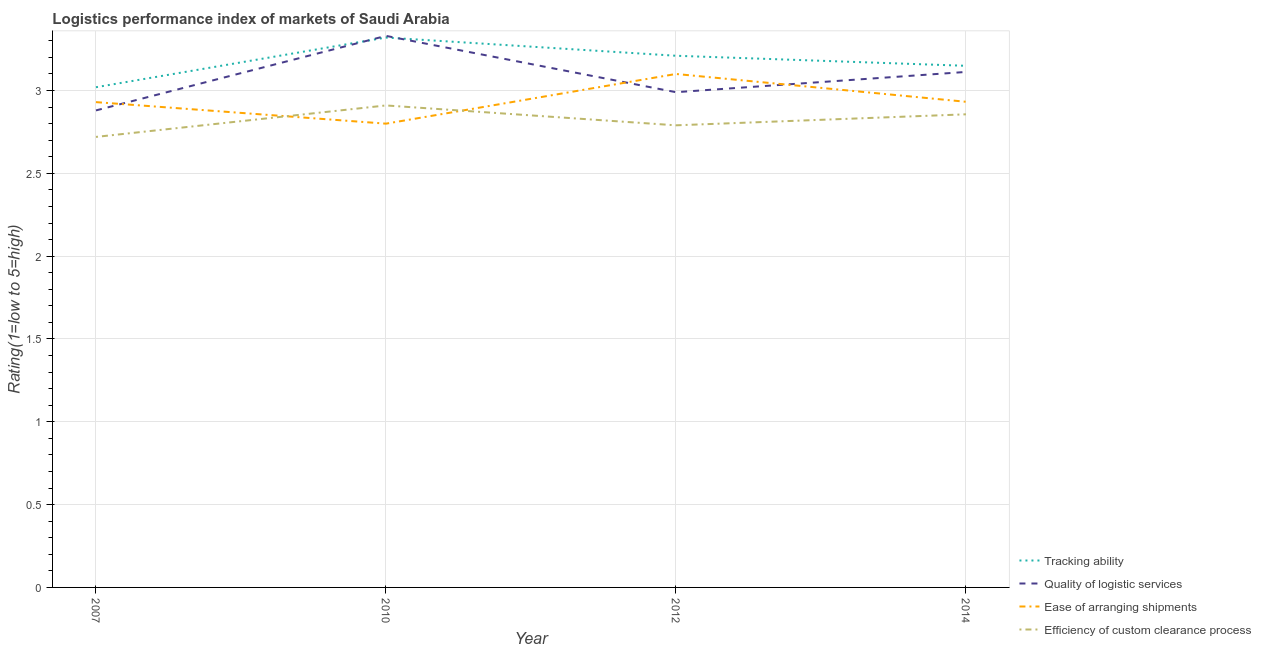How many different coloured lines are there?
Ensure brevity in your answer.  4. Does the line corresponding to lpi rating of efficiency of custom clearance process intersect with the line corresponding to lpi rating of quality of logistic services?
Your answer should be compact. No. Is the number of lines equal to the number of legend labels?
Your response must be concise. Yes. What is the lpi rating of efficiency of custom clearance process in 2014?
Your response must be concise. 2.86. Across all years, what is the maximum lpi rating of quality of logistic services?
Provide a short and direct response. 3.33. Across all years, what is the minimum lpi rating of tracking ability?
Ensure brevity in your answer.  3.02. In which year was the lpi rating of ease of arranging shipments maximum?
Keep it short and to the point. 2012. In which year was the lpi rating of efficiency of custom clearance process minimum?
Provide a succinct answer. 2007. What is the total lpi rating of ease of arranging shipments in the graph?
Offer a very short reply. 11.76. What is the difference between the lpi rating of ease of arranging shipments in 2010 and that in 2012?
Your answer should be compact. -0.3. What is the difference between the lpi rating of ease of arranging shipments in 2014 and the lpi rating of efficiency of custom clearance process in 2010?
Make the answer very short. 0.02. What is the average lpi rating of efficiency of custom clearance process per year?
Offer a terse response. 2.82. In the year 2012, what is the difference between the lpi rating of efficiency of custom clearance process and lpi rating of ease of arranging shipments?
Your answer should be compact. -0.31. In how many years, is the lpi rating of quality of logistic services greater than 2.1?
Keep it short and to the point. 4. What is the ratio of the lpi rating of quality of logistic services in 2007 to that in 2012?
Your response must be concise. 0.96. What is the difference between the highest and the second highest lpi rating of quality of logistic services?
Make the answer very short. 0.22. What is the difference between the highest and the lowest lpi rating of ease of arranging shipments?
Give a very brief answer. 0.3. In how many years, is the lpi rating of tracking ability greater than the average lpi rating of tracking ability taken over all years?
Your answer should be compact. 2. Is the sum of the lpi rating of efficiency of custom clearance process in 2010 and 2014 greater than the maximum lpi rating of quality of logistic services across all years?
Your answer should be compact. Yes. Is it the case that in every year, the sum of the lpi rating of tracking ability and lpi rating of ease of arranging shipments is greater than the sum of lpi rating of efficiency of custom clearance process and lpi rating of quality of logistic services?
Offer a terse response. Yes. Is the lpi rating of quality of logistic services strictly less than the lpi rating of efficiency of custom clearance process over the years?
Keep it short and to the point. No. How many years are there in the graph?
Your answer should be compact. 4. Are the values on the major ticks of Y-axis written in scientific E-notation?
Offer a terse response. No. Does the graph contain any zero values?
Offer a very short reply. No. Does the graph contain grids?
Give a very brief answer. Yes. Where does the legend appear in the graph?
Ensure brevity in your answer.  Bottom right. How many legend labels are there?
Make the answer very short. 4. How are the legend labels stacked?
Your answer should be compact. Vertical. What is the title of the graph?
Ensure brevity in your answer.  Logistics performance index of markets of Saudi Arabia. What is the label or title of the Y-axis?
Keep it short and to the point. Rating(1=low to 5=high). What is the Rating(1=low to 5=high) of Tracking ability in 2007?
Provide a succinct answer. 3.02. What is the Rating(1=low to 5=high) of Quality of logistic services in 2007?
Make the answer very short. 2.88. What is the Rating(1=low to 5=high) in Ease of arranging shipments in 2007?
Ensure brevity in your answer.  2.93. What is the Rating(1=low to 5=high) in Efficiency of custom clearance process in 2007?
Provide a short and direct response. 2.72. What is the Rating(1=low to 5=high) of Tracking ability in 2010?
Offer a terse response. 3.32. What is the Rating(1=low to 5=high) in Quality of logistic services in 2010?
Keep it short and to the point. 3.33. What is the Rating(1=low to 5=high) of Ease of arranging shipments in 2010?
Make the answer very short. 2.8. What is the Rating(1=low to 5=high) in Efficiency of custom clearance process in 2010?
Offer a very short reply. 2.91. What is the Rating(1=low to 5=high) of Tracking ability in 2012?
Your answer should be very brief. 3.21. What is the Rating(1=low to 5=high) in Quality of logistic services in 2012?
Offer a very short reply. 2.99. What is the Rating(1=low to 5=high) in Efficiency of custom clearance process in 2012?
Your answer should be very brief. 2.79. What is the Rating(1=low to 5=high) in Tracking ability in 2014?
Make the answer very short. 3.15. What is the Rating(1=low to 5=high) of Quality of logistic services in 2014?
Provide a short and direct response. 3.11. What is the Rating(1=low to 5=high) of Ease of arranging shipments in 2014?
Offer a terse response. 2.93. What is the Rating(1=low to 5=high) of Efficiency of custom clearance process in 2014?
Ensure brevity in your answer.  2.86. Across all years, what is the maximum Rating(1=low to 5=high) in Tracking ability?
Offer a very short reply. 3.32. Across all years, what is the maximum Rating(1=low to 5=high) in Quality of logistic services?
Offer a terse response. 3.33. Across all years, what is the maximum Rating(1=low to 5=high) in Efficiency of custom clearance process?
Your answer should be compact. 2.91. Across all years, what is the minimum Rating(1=low to 5=high) in Tracking ability?
Ensure brevity in your answer.  3.02. Across all years, what is the minimum Rating(1=low to 5=high) in Quality of logistic services?
Offer a terse response. 2.88. Across all years, what is the minimum Rating(1=low to 5=high) in Efficiency of custom clearance process?
Make the answer very short. 2.72. What is the total Rating(1=low to 5=high) of Tracking ability in the graph?
Your answer should be compact. 12.7. What is the total Rating(1=low to 5=high) in Quality of logistic services in the graph?
Make the answer very short. 12.31. What is the total Rating(1=low to 5=high) in Ease of arranging shipments in the graph?
Offer a terse response. 11.76. What is the total Rating(1=low to 5=high) of Efficiency of custom clearance process in the graph?
Give a very brief answer. 11.28. What is the difference between the Rating(1=low to 5=high) of Quality of logistic services in 2007 and that in 2010?
Your answer should be very brief. -0.45. What is the difference between the Rating(1=low to 5=high) of Ease of arranging shipments in 2007 and that in 2010?
Ensure brevity in your answer.  0.13. What is the difference between the Rating(1=low to 5=high) in Efficiency of custom clearance process in 2007 and that in 2010?
Your answer should be compact. -0.19. What is the difference between the Rating(1=low to 5=high) of Tracking ability in 2007 and that in 2012?
Give a very brief answer. -0.19. What is the difference between the Rating(1=low to 5=high) in Quality of logistic services in 2007 and that in 2012?
Give a very brief answer. -0.11. What is the difference between the Rating(1=low to 5=high) in Ease of arranging shipments in 2007 and that in 2012?
Your answer should be compact. -0.17. What is the difference between the Rating(1=low to 5=high) in Efficiency of custom clearance process in 2007 and that in 2012?
Provide a short and direct response. -0.07. What is the difference between the Rating(1=low to 5=high) in Tracking ability in 2007 and that in 2014?
Give a very brief answer. -0.13. What is the difference between the Rating(1=low to 5=high) in Quality of logistic services in 2007 and that in 2014?
Provide a short and direct response. -0.23. What is the difference between the Rating(1=low to 5=high) in Ease of arranging shipments in 2007 and that in 2014?
Provide a succinct answer. -0. What is the difference between the Rating(1=low to 5=high) in Efficiency of custom clearance process in 2007 and that in 2014?
Your response must be concise. -0.14. What is the difference between the Rating(1=low to 5=high) in Tracking ability in 2010 and that in 2012?
Offer a terse response. 0.11. What is the difference between the Rating(1=low to 5=high) in Quality of logistic services in 2010 and that in 2012?
Make the answer very short. 0.34. What is the difference between the Rating(1=low to 5=high) in Ease of arranging shipments in 2010 and that in 2012?
Offer a terse response. -0.3. What is the difference between the Rating(1=low to 5=high) of Efficiency of custom clearance process in 2010 and that in 2012?
Your answer should be very brief. 0.12. What is the difference between the Rating(1=low to 5=high) in Tracking ability in 2010 and that in 2014?
Provide a short and direct response. 0.17. What is the difference between the Rating(1=low to 5=high) of Quality of logistic services in 2010 and that in 2014?
Provide a short and direct response. 0.22. What is the difference between the Rating(1=low to 5=high) of Ease of arranging shipments in 2010 and that in 2014?
Give a very brief answer. -0.13. What is the difference between the Rating(1=low to 5=high) of Efficiency of custom clearance process in 2010 and that in 2014?
Offer a very short reply. 0.05. What is the difference between the Rating(1=low to 5=high) in Tracking ability in 2012 and that in 2014?
Your answer should be very brief. 0.06. What is the difference between the Rating(1=low to 5=high) of Quality of logistic services in 2012 and that in 2014?
Ensure brevity in your answer.  -0.12. What is the difference between the Rating(1=low to 5=high) of Ease of arranging shipments in 2012 and that in 2014?
Offer a very short reply. 0.17. What is the difference between the Rating(1=low to 5=high) of Efficiency of custom clearance process in 2012 and that in 2014?
Provide a succinct answer. -0.07. What is the difference between the Rating(1=low to 5=high) in Tracking ability in 2007 and the Rating(1=low to 5=high) in Quality of logistic services in 2010?
Ensure brevity in your answer.  -0.31. What is the difference between the Rating(1=low to 5=high) in Tracking ability in 2007 and the Rating(1=low to 5=high) in Ease of arranging shipments in 2010?
Give a very brief answer. 0.22. What is the difference between the Rating(1=low to 5=high) of Tracking ability in 2007 and the Rating(1=low to 5=high) of Efficiency of custom clearance process in 2010?
Keep it short and to the point. 0.11. What is the difference between the Rating(1=low to 5=high) of Quality of logistic services in 2007 and the Rating(1=low to 5=high) of Ease of arranging shipments in 2010?
Give a very brief answer. 0.08. What is the difference between the Rating(1=low to 5=high) of Quality of logistic services in 2007 and the Rating(1=low to 5=high) of Efficiency of custom clearance process in 2010?
Give a very brief answer. -0.03. What is the difference between the Rating(1=low to 5=high) in Tracking ability in 2007 and the Rating(1=low to 5=high) in Ease of arranging shipments in 2012?
Your answer should be very brief. -0.08. What is the difference between the Rating(1=low to 5=high) in Tracking ability in 2007 and the Rating(1=low to 5=high) in Efficiency of custom clearance process in 2012?
Give a very brief answer. 0.23. What is the difference between the Rating(1=low to 5=high) in Quality of logistic services in 2007 and the Rating(1=low to 5=high) in Ease of arranging shipments in 2012?
Provide a succinct answer. -0.22. What is the difference between the Rating(1=low to 5=high) of Quality of logistic services in 2007 and the Rating(1=low to 5=high) of Efficiency of custom clearance process in 2012?
Give a very brief answer. 0.09. What is the difference between the Rating(1=low to 5=high) in Ease of arranging shipments in 2007 and the Rating(1=low to 5=high) in Efficiency of custom clearance process in 2012?
Provide a short and direct response. 0.14. What is the difference between the Rating(1=low to 5=high) in Tracking ability in 2007 and the Rating(1=low to 5=high) in Quality of logistic services in 2014?
Keep it short and to the point. -0.09. What is the difference between the Rating(1=low to 5=high) in Tracking ability in 2007 and the Rating(1=low to 5=high) in Ease of arranging shipments in 2014?
Ensure brevity in your answer.  0.09. What is the difference between the Rating(1=low to 5=high) of Tracking ability in 2007 and the Rating(1=low to 5=high) of Efficiency of custom clearance process in 2014?
Keep it short and to the point. 0.16. What is the difference between the Rating(1=low to 5=high) in Quality of logistic services in 2007 and the Rating(1=low to 5=high) in Ease of arranging shipments in 2014?
Offer a terse response. -0.05. What is the difference between the Rating(1=low to 5=high) of Quality of logistic services in 2007 and the Rating(1=low to 5=high) of Efficiency of custom clearance process in 2014?
Offer a terse response. 0.02. What is the difference between the Rating(1=low to 5=high) in Ease of arranging shipments in 2007 and the Rating(1=low to 5=high) in Efficiency of custom clearance process in 2014?
Offer a very short reply. 0.07. What is the difference between the Rating(1=low to 5=high) of Tracking ability in 2010 and the Rating(1=low to 5=high) of Quality of logistic services in 2012?
Ensure brevity in your answer.  0.33. What is the difference between the Rating(1=low to 5=high) of Tracking ability in 2010 and the Rating(1=low to 5=high) of Ease of arranging shipments in 2012?
Ensure brevity in your answer.  0.22. What is the difference between the Rating(1=low to 5=high) of Tracking ability in 2010 and the Rating(1=low to 5=high) of Efficiency of custom clearance process in 2012?
Ensure brevity in your answer.  0.53. What is the difference between the Rating(1=low to 5=high) in Quality of logistic services in 2010 and the Rating(1=low to 5=high) in Ease of arranging shipments in 2012?
Ensure brevity in your answer.  0.23. What is the difference between the Rating(1=low to 5=high) of Quality of logistic services in 2010 and the Rating(1=low to 5=high) of Efficiency of custom clearance process in 2012?
Provide a succinct answer. 0.54. What is the difference between the Rating(1=low to 5=high) of Ease of arranging shipments in 2010 and the Rating(1=low to 5=high) of Efficiency of custom clearance process in 2012?
Keep it short and to the point. 0.01. What is the difference between the Rating(1=low to 5=high) of Tracking ability in 2010 and the Rating(1=low to 5=high) of Quality of logistic services in 2014?
Give a very brief answer. 0.21. What is the difference between the Rating(1=low to 5=high) of Tracking ability in 2010 and the Rating(1=low to 5=high) of Ease of arranging shipments in 2014?
Your answer should be very brief. 0.39. What is the difference between the Rating(1=low to 5=high) of Tracking ability in 2010 and the Rating(1=low to 5=high) of Efficiency of custom clearance process in 2014?
Offer a terse response. 0.46. What is the difference between the Rating(1=low to 5=high) in Quality of logistic services in 2010 and the Rating(1=low to 5=high) in Ease of arranging shipments in 2014?
Your response must be concise. 0.4. What is the difference between the Rating(1=low to 5=high) of Quality of logistic services in 2010 and the Rating(1=low to 5=high) of Efficiency of custom clearance process in 2014?
Offer a terse response. 0.47. What is the difference between the Rating(1=low to 5=high) in Ease of arranging shipments in 2010 and the Rating(1=low to 5=high) in Efficiency of custom clearance process in 2014?
Keep it short and to the point. -0.06. What is the difference between the Rating(1=low to 5=high) in Tracking ability in 2012 and the Rating(1=low to 5=high) in Quality of logistic services in 2014?
Make the answer very short. 0.1. What is the difference between the Rating(1=low to 5=high) of Tracking ability in 2012 and the Rating(1=low to 5=high) of Ease of arranging shipments in 2014?
Your answer should be very brief. 0.28. What is the difference between the Rating(1=low to 5=high) of Tracking ability in 2012 and the Rating(1=low to 5=high) of Efficiency of custom clearance process in 2014?
Your answer should be compact. 0.35. What is the difference between the Rating(1=low to 5=high) of Quality of logistic services in 2012 and the Rating(1=low to 5=high) of Ease of arranging shipments in 2014?
Provide a succinct answer. 0.06. What is the difference between the Rating(1=low to 5=high) in Quality of logistic services in 2012 and the Rating(1=low to 5=high) in Efficiency of custom clearance process in 2014?
Your answer should be compact. 0.13. What is the difference between the Rating(1=low to 5=high) of Ease of arranging shipments in 2012 and the Rating(1=low to 5=high) of Efficiency of custom clearance process in 2014?
Make the answer very short. 0.24. What is the average Rating(1=low to 5=high) in Tracking ability per year?
Give a very brief answer. 3.17. What is the average Rating(1=low to 5=high) in Quality of logistic services per year?
Provide a succinct answer. 3.08. What is the average Rating(1=low to 5=high) of Ease of arranging shipments per year?
Provide a short and direct response. 2.94. What is the average Rating(1=low to 5=high) of Efficiency of custom clearance process per year?
Offer a very short reply. 2.82. In the year 2007, what is the difference between the Rating(1=low to 5=high) of Tracking ability and Rating(1=low to 5=high) of Quality of logistic services?
Offer a very short reply. 0.14. In the year 2007, what is the difference between the Rating(1=low to 5=high) of Tracking ability and Rating(1=low to 5=high) of Ease of arranging shipments?
Your answer should be very brief. 0.09. In the year 2007, what is the difference between the Rating(1=low to 5=high) of Tracking ability and Rating(1=low to 5=high) of Efficiency of custom clearance process?
Ensure brevity in your answer.  0.3. In the year 2007, what is the difference between the Rating(1=low to 5=high) in Quality of logistic services and Rating(1=low to 5=high) in Efficiency of custom clearance process?
Keep it short and to the point. 0.16. In the year 2007, what is the difference between the Rating(1=low to 5=high) in Ease of arranging shipments and Rating(1=low to 5=high) in Efficiency of custom clearance process?
Offer a terse response. 0.21. In the year 2010, what is the difference between the Rating(1=low to 5=high) of Tracking ability and Rating(1=low to 5=high) of Quality of logistic services?
Offer a very short reply. -0.01. In the year 2010, what is the difference between the Rating(1=low to 5=high) in Tracking ability and Rating(1=low to 5=high) in Ease of arranging shipments?
Your answer should be very brief. 0.52. In the year 2010, what is the difference between the Rating(1=low to 5=high) of Tracking ability and Rating(1=low to 5=high) of Efficiency of custom clearance process?
Your response must be concise. 0.41. In the year 2010, what is the difference between the Rating(1=low to 5=high) of Quality of logistic services and Rating(1=low to 5=high) of Ease of arranging shipments?
Your answer should be very brief. 0.53. In the year 2010, what is the difference between the Rating(1=low to 5=high) in Quality of logistic services and Rating(1=low to 5=high) in Efficiency of custom clearance process?
Your response must be concise. 0.42. In the year 2010, what is the difference between the Rating(1=low to 5=high) of Ease of arranging shipments and Rating(1=low to 5=high) of Efficiency of custom clearance process?
Provide a succinct answer. -0.11. In the year 2012, what is the difference between the Rating(1=low to 5=high) of Tracking ability and Rating(1=low to 5=high) of Quality of logistic services?
Your answer should be very brief. 0.22. In the year 2012, what is the difference between the Rating(1=low to 5=high) in Tracking ability and Rating(1=low to 5=high) in Ease of arranging shipments?
Offer a terse response. 0.11. In the year 2012, what is the difference between the Rating(1=low to 5=high) of Tracking ability and Rating(1=low to 5=high) of Efficiency of custom clearance process?
Ensure brevity in your answer.  0.42. In the year 2012, what is the difference between the Rating(1=low to 5=high) of Quality of logistic services and Rating(1=low to 5=high) of Ease of arranging shipments?
Ensure brevity in your answer.  -0.11. In the year 2012, what is the difference between the Rating(1=low to 5=high) of Ease of arranging shipments and Rating(1=low to 5=high) of Efficiency of custom clearance process?
Offer a very short reply. 0.31. In the year 2014, what is the difference between the Rating(1=low to 5=high) of Tracking ability and Rating(1=low to 5=high) of Quality of logistic services?
Offer a very short reply. 0.04. In the year 2014, what is the difference between the Rating(1=low to 5=high) of Tracking ability and Rating(1=low to 5=high) of Ease of arranging shipments?
Offer a terse response. 0.22. In the year 2014, what is the difference between the Rating(1=low to 5=high) in Tracking ability and Rating(1=low to 5=high) in Efficiency of custom clearance process?
Ensure brevity in your answer.  0.29. In the year 2014, what is the difference between the Rating(1=low to 5=high) of Quality of logistic services and Rating(1=low to 5=high) of Ease of arranging shipments?
Make the answer very short. 0.18. In the year 2014, what is the difference between the Rating(1=low to 5=high) of Quality of logistic services and Rating(1=low to 5=high) of Efficiency of custom clearance process?
Keep it short and to the point. 0.26. In the year 2014, what is the difference between the Rating(1=low to 5=high) in Ease of arranging shipments and Rating(1=low to 5=high) in Efficiency of custom clearance process?
Provide a succinct answer. 0.08. What is the ratio of the Rating(1=low to 5=high) in Tracking ability in 2007 to that in 2010?
Offer a very short reply. 0.91. What is the ratio of the Rating(1=low to 5=high) in Quality of logistic services in 2007 to that in 2010?
Offer a very short reply. 0.86. What is the ratio of the Rating(1=low to 5=high) of Ease of arranging shipments in 2007 to that in 2010?
Your response must be concise. 1.05. What is the ratio of the Rating(1=low to 5=high) in Efficiency of custom clearance process in 2007 to that in 2010?
Provide a short and direct response. 0.93. What is the ratio of the Rating(1=low to 5=high) of Tracking ability in 2007 to that in 2012?
Make the answer very short. 0.94. What is the ratio of the Rating(1=low to 5=high) of Quality of logistic services in 2007 to that in 2012?
Keep it short and to the point. 0.96. What is the ratio of the Rating(1=low to 5=high) in Ease of arranging shipments in 2007 to that in 2012?
Your answer should be very brief. 0.95. What is the ratio of the Rating(1=low to 5=high) in Efficiency of custom clearance process in 2007 to that in 2012?
Give a very brief answer. 0.97. What is the ratio of the Rating(1=low to 5=high) of Tracking ability in 2007 to that in 2014?
Provide a short and direct response. 0.96. What is the ratio of the Rating(1=low to 5=high) of Quality of logistic services in 2007 to that in 2014?
Make the answer very short. 0.93. What is the ratio of the Rating(1=low to 5=high) of Ease of arranging shipments in 2007 to that in 2014?
Give a very brief answer. 1. What is the ratio of the Rating(1=low to 5=high) in Efficiency of custom clearance process in 2007 to that in 2014?
Your response must be concise. 0.95. What is the ratio of the Rating(1=low to 5=high) of Tracking ability in 2010 to that in 2012?
Make the answer very short. 1.03. What is the ratio of the Rating(1=low to 5=high) of Quality of logistic services in 2010 to that in 2012?
Give a very brief answer. 1.11. What is the ratio of the Rating(1=low to 5=high) of Ease of arranging shipments in 2010 to that in 2012?
Give a very brief answer. 0.9. What is the ratio of the Rating(1=low to 5=high) in Efficiency of custom clearance process in 2010 to that in 2012?
Keep it short and to the point. 1.04. What is the ratio of the Rating(1=low to 5=high) of Tracking ability in 2010 to that in 2014?
Your response must be concise. 1.05. What is the ratio of the Rating(1=low to 5=high) in Quality of logistic services in 2010 to that in 2014?
Offer a terse response. 1.07. What is the ratio of the Rating(1=low to 5=high) of Ease of arranging shipments in 2010 to that in 2014?
Make the answer very short. 0.95. What is the ratio of the Rating(1=low to 5=high) in Efficiency of custom clearance process in 2010 to that in 2014?
Your answer should be compact. 1.02. What is the ratio of the Rating(1=low to 5=high) in Tracking ability in 2012 to that in 2014?
Give a very brief answer. 1.02. What is the ratio of the Rating(1=low to 5=high) of Quality of logistic services in 2012 to that in 2014?
Keep it short and to the point. 0.96. What is the ratio of the Rating(1=low to 5=high) in Ease of arranging shipments in 2012 to that in 2014?
Your answer should be compact. 1.06. What is the ratio of the Rating(1=low to 5=high) of Efficiency of custom clearance process in 2012 to that in 2014?
Make the answer very short. 0.98. What is the difference between the highest and the second highest Rating(1=low to 5=high) in Tracking ability?
Provide a short and direct response. 0.11. What is the difference between the highest and the second highest Rating(1=low to 5=high) of Quality of logistic services?
Make the answer very short. 0.22. What is the difference between the highest and the second highest Rating(1=low to 5=high) of Ease of arranging shipments?
Make the answer very short. 0.17. What is the difference between the highest and the second highest Rating(1=low to 5=high) in Efficiency of custom clearance process?
Provide a short and direct response. 0.05. What is the difference between the highest and the lowest Rating(1=low to 5=high) of Tracking ability?
Provide a short and direct response. 0.3. What is the difference between the highest and the lowest Rating(1=low to 5=high) of Quality of logistic services?
Make the answer very short. 0.45. What is the difference between the highest and the lowest Rating(1=low to 5=high) in Efficiency of custom clearance process?
Your response must be concise. 0.19. 